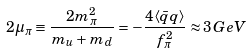<formula> <loc_0><loc_0><loc_500><loc_500>2 \mu _ { \pi } \equiv \frac { 2 m _ { \pi } ^ { 2 } } { m _ { u } + m _ { d } } = - \frac { 4 \langle \bar { q } q \rangle } { f _ { \pi } ^ { 2 } } \approx 3 \, G e V</formula> 